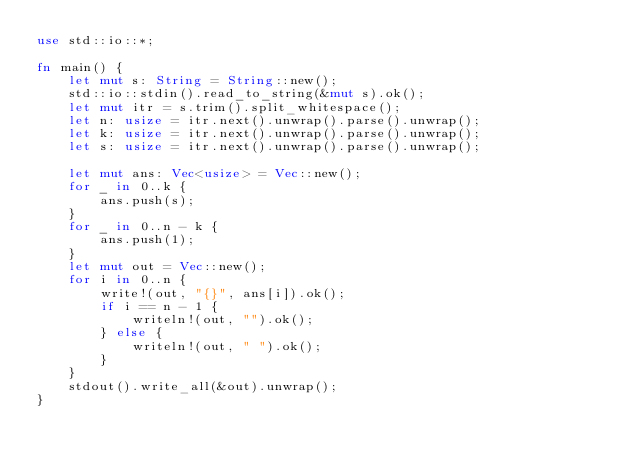<code> <loc_0><loc_0><loc_500><loc_500><_Rust_>use std::io::*;

fn main() {
    let mut s: String = String::new();
    std::io::stdin().read_to_string(&mut s).ok();
    let mut itr = s.trim().split_whitespace();
    let n: usize = itr.next().unwrap().parse().unwrap();
    let k: usize = itr.next().unwrap().parse().unwrap();
    let s: usize = itr.next().unwrap().parse().unwrap();

    let mut ans: Vec<usize> = Vec::new();
    for _ in 0..k {
        ans.push(s);
    }
    for _ in 0..n - k {
        ans.push(1);
    }
    let mut out = Vec::new();
    for i in 0..n {
        write!(out, "{}", ans[i]).ok();
        if i == n - 1 {
            writeln!(out, "").ok();
        } else {
            writeln!(out, " ").ok();
        }
    }
    stdout().write_all(&out).unwrap();
}
</code> 